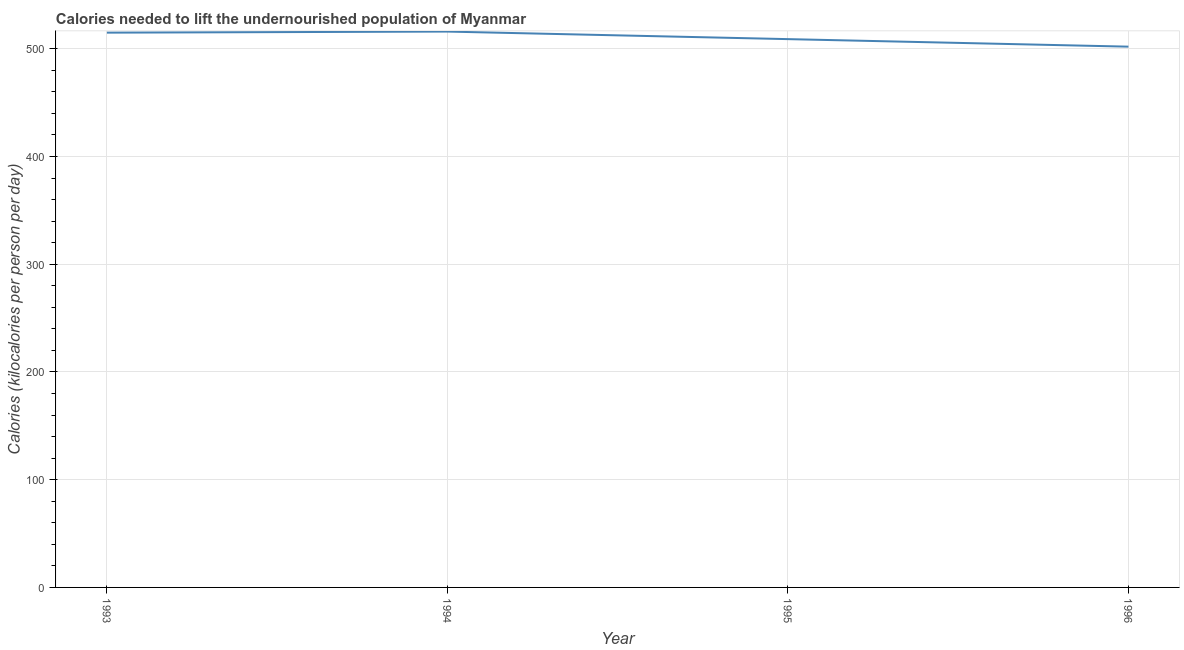What is the depth of food deficit in 1995?
Offer a terse response. 509. Across all years, what is the maximum depth of food deficit?
Keep it short and to the point. 516. Across all years, what is the minimum depth of food deficit?
Provide a succinct answer. 502. In which year was the depth of food deficit maximum?
Provide a short and direct response. 1994. In which year was the depth of food deficit minimum?
Offer a very short reply. 1996. What is the sum of the depth of food deficit?
Offer a very short reply. 2042. What is the difference between the depth of food deficit in 1994 and 1995?
Provide a short and direct response. 7. What is the average depth of food deficit per year?
Give a very brief answer. 510.5. What is the median depth of food deficit?
Keep it short and to the point. 512. In how many years, is the depth of food deficit greater than 400 kilocalories?
Provide a succinct answer. 4. What is the ratio of the depth of food deficit in 1994 to that in 1996?
Provide a short and direct response. 1.03. What is the difference between the highest and the lowest depth of food deficit?
Keep it short and to the point. 14. In how many years, is the depth of food deficit greater than the average depth of food deficit taken over all years?
Give a very brief answer. 2. Does the depth of food deficit monotonically increase over the years?
Provide a short and direct response. No. How many lines are there?
Give a very brief answer. 1. What is the difference between two consecutive major ticks on the Y-axis?
Provide a succinct answer. 100. Are the values on the major ticks of Y-axis written in scientific E-notation?
Ensure brevity in your answer.  No. What is the title of the graph?
Offer a very short reply. Calories needed to lift the undernourished population of Myanmar. What is the label or title of the Y-axis?
Ensure brevity in your answer.  Calories (kilocalories per person per day). What is the Calories (kilocalories per person per day) in 1993?
Your answer should be compact. 515. What is the Calories (kilocalories per person per day) in 1994?
Your answer should be very brief. 516. What is the Calories (kilocalories per person per day) in 1995?
Provide a succinct answer. 509. What is the Calories (kilocalories per person per day) in 1996?
Ensure brevity in your answer.  502. What is the difference between the Calories (kilocalories per person per day) in 1993 and 1996?
Your answer should be compact. 13. What is the difference between the Calories (kilocalories per person per day) in 1994 and 1996?
Ensure brevity in your answer.  14. What is the ratio of the Calories (kilocalories per person per day) in 1993 to that in 1994?
Give a very brief answer. 1. What is the ratio of the Calories (kilocalories per person per day) in 1993 to that in 1996?
Offer a very short reply. 1.03. What is the ratio of the Calories (kilocalories per person per day) in 1994 to that in 1996?
Keep it short and to the point. 1.03. What is the ratio of the Calories (kilocalories per person per day) in 1995 to that in 1996?
Offer a terse response. 1.01. 